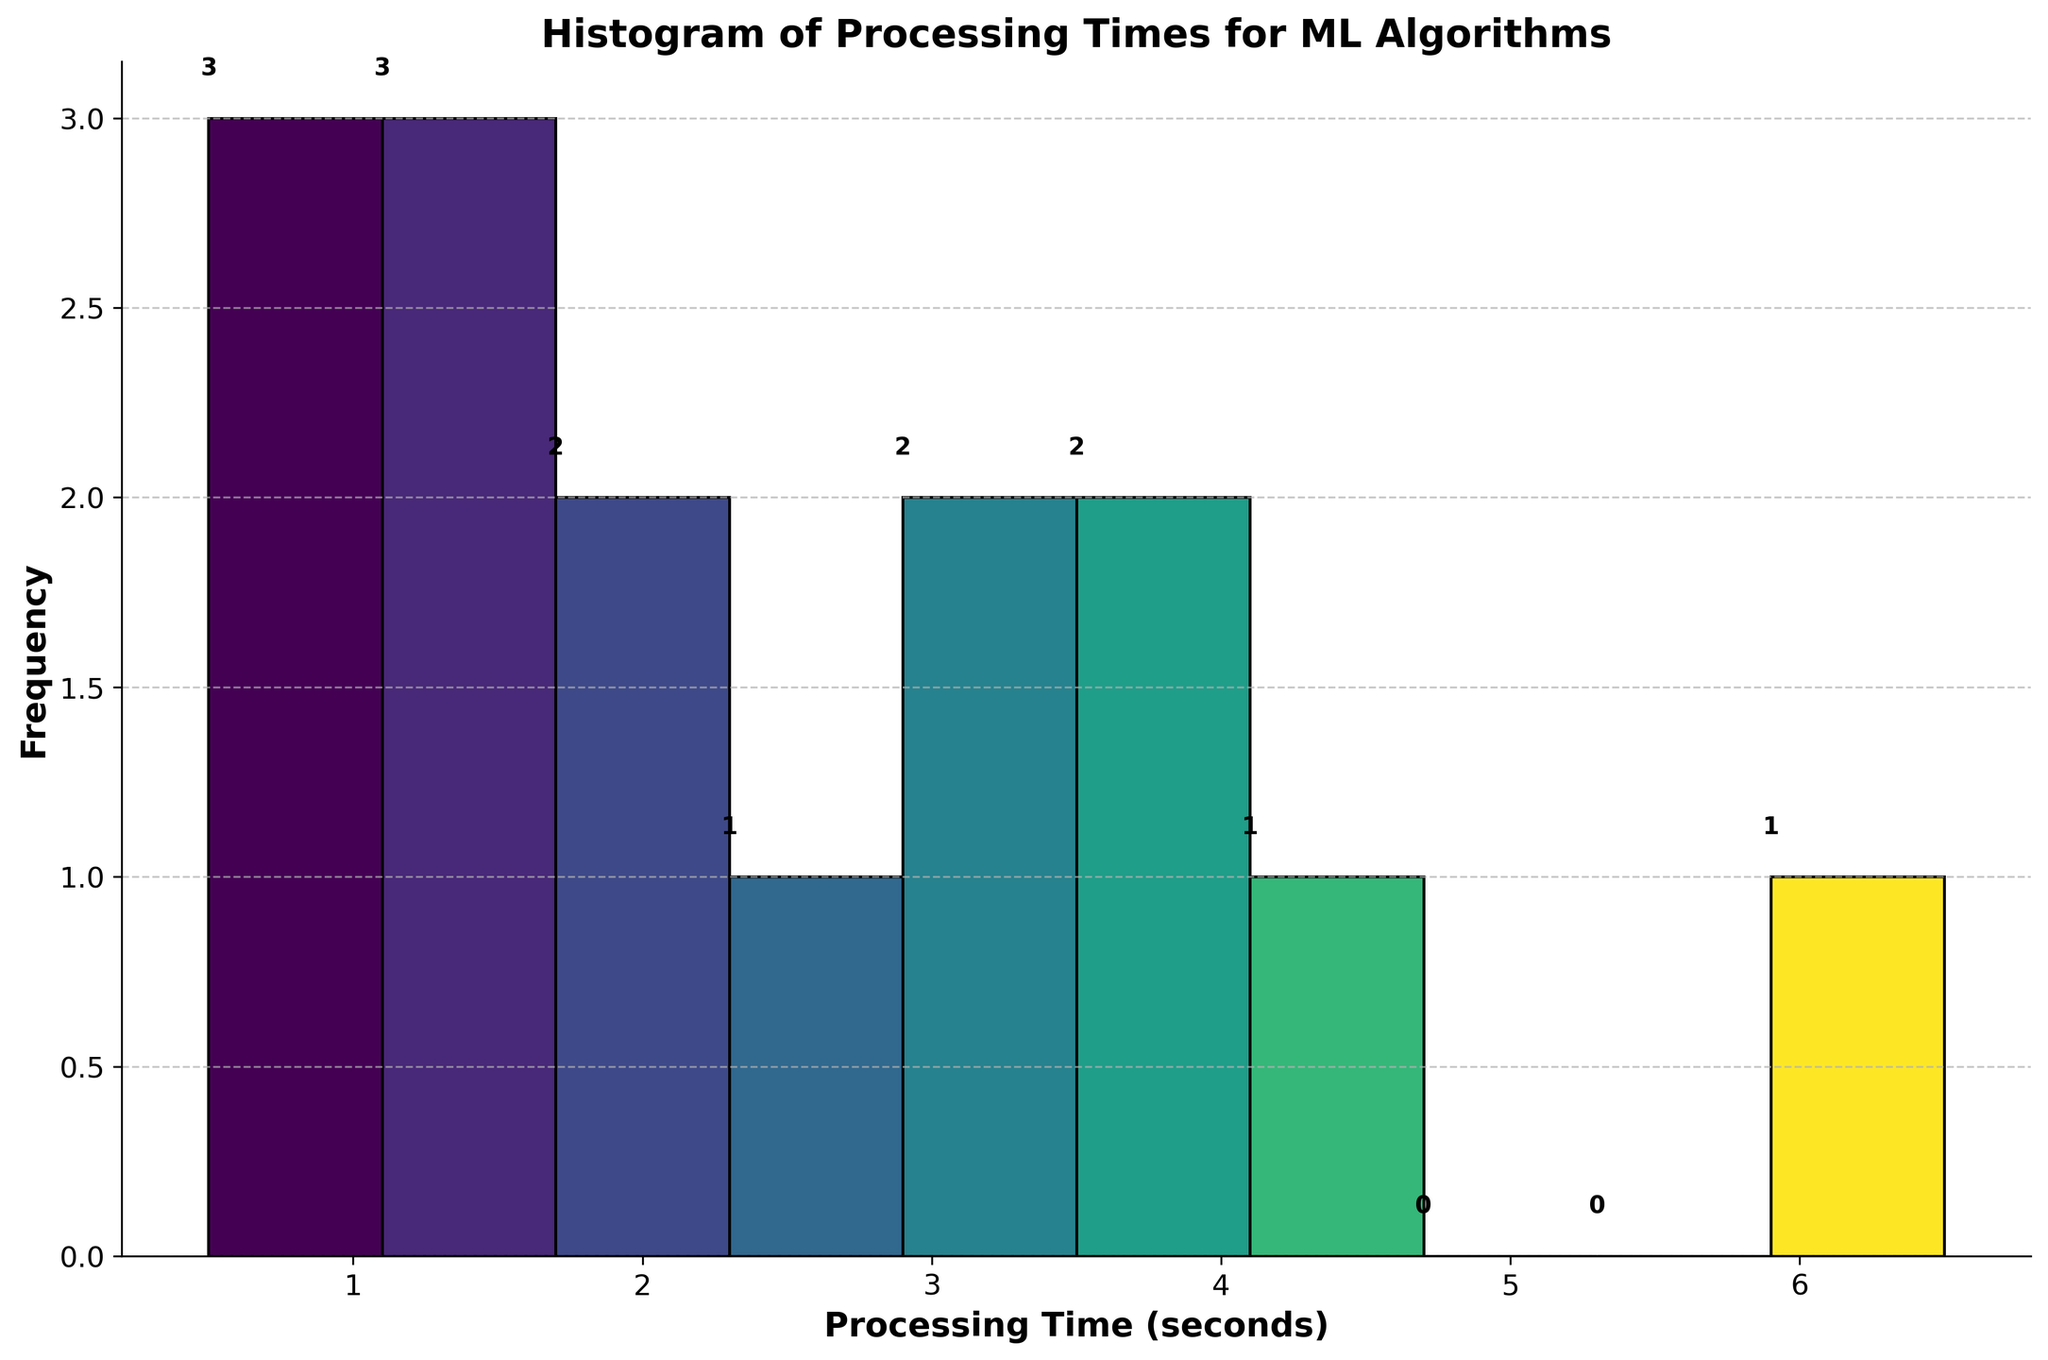What is the title of the histogram? The title is prominently displayed at the top of the histogram.
Answer: Histogram of Processing Times for ML Algorithms What is the x-axis label? The x-axis label is located directly below the x-axis, describing what the axis represents.
Answer: Processing Time (seconds) How many bins are used in the histogram? By counting the distinct bars (bins) in the histogram, we determine the number of bins.
Answer: 10 Which bin contains the highest frequency of processing times? The bin with the highest frequency has the tallest bar. By looking for the tallest bar, we identify the corresponding processing time range on the x-axis.
Answer: 2-2.75 seconds What is the frequency of the bin containing the highest processing times? Identify the height of the bar at the far right of the histogram, which represents the highest processing time.
Answer: 1 How many algorithms have a processing time between 1.5 and 2.5 seconds? Identify the bars corresponding to the 1.5 to 2.5 second range and count the total frequency for this range.
Answer: 3 What is the total number of algorithms displayed in the histogram? Sum all the frequencies represented by each bar in the histogram.
Answer: 15 Which algorithm has the lowest processing time? By comparing the individual data points listed, the algorithm with the smallest value is identified.
Answer: Linear Regression Is there a processing time range with no algorithms? Examine the histogram to see if there is any bin with zero frequency, which means no algorithms fall into that range.
Answer: No Compare the frequency of processing times between 0.5-1.5 seconds and 3-4 seconds. Which range has a higher frequency? Add the frequencies of the bars in the 0.5-1.5 and 3-4 second ranges, then compare the sums to determine which is higher.
Answer: 0.5-1.5 seconds (4 vs 3) 